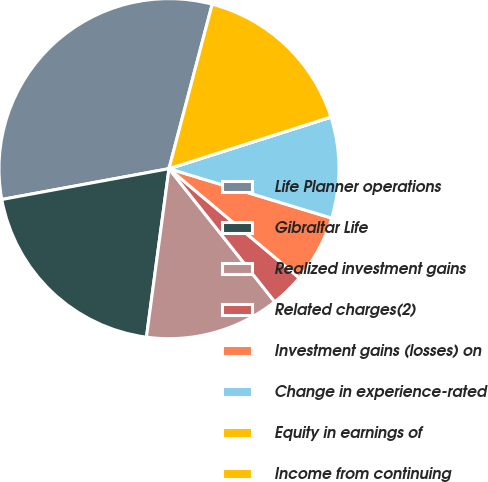Convert chart to OTSL. <chart><loc_0><loc_0><loc_500><loc_500><pie_chart><fcel>Life Planner operations<fcel>Gibraltar Life<fcel>Realized investment gains<fcel>Related charges(2)<fcel>Investment gains (losses) on<fcel>Change in experience-rated<fcel>Equity in earnings of<fcel>Income from continuing<nl><fcel>31.99%<fcel>19.98%<fcel>12.8%<fcel>3.21%<fcel>6.41%<fcel>9.6%<fcel>0.01%<fcel>16.0%<nl></chart> 